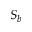<formula> <loc_0><loc_0><loc_500><loc_500>S _ { b }</formula> 